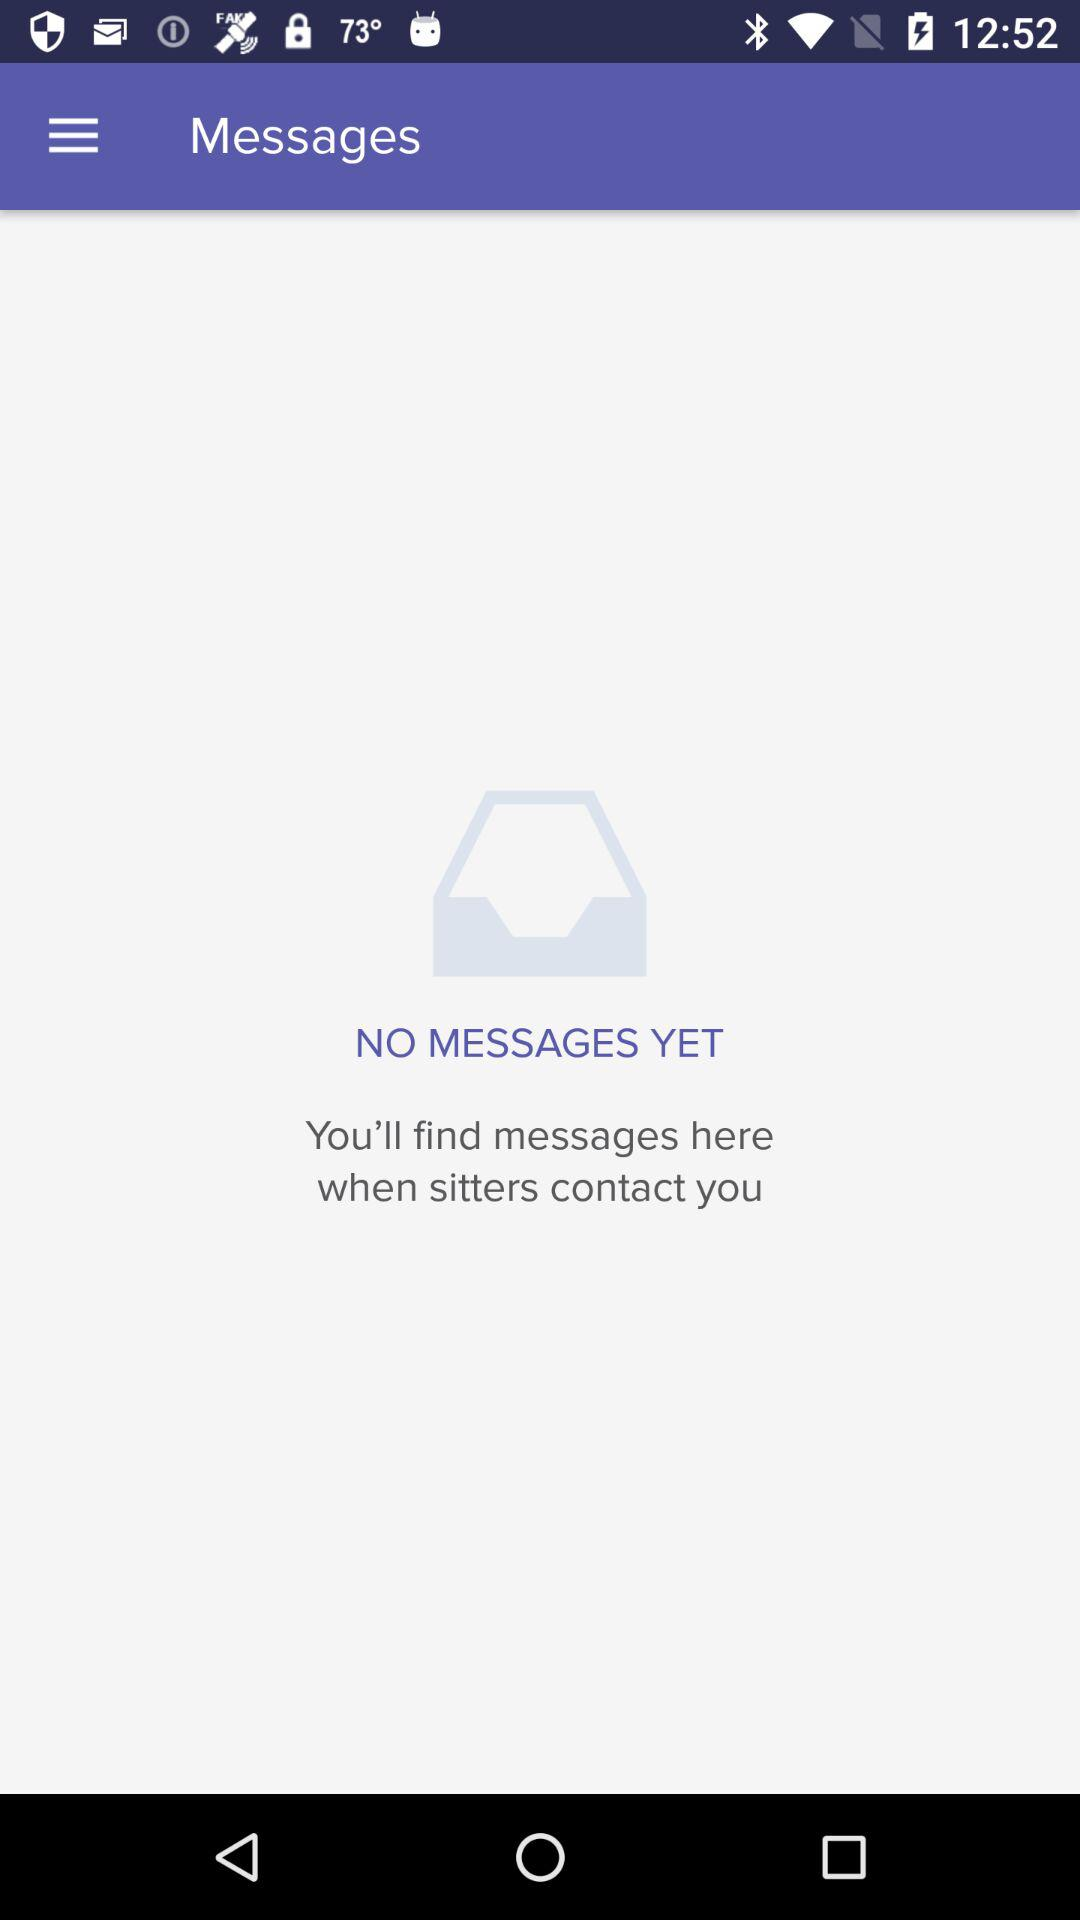How many messages have been received?
Answer the question using a single word or phrase. 0 